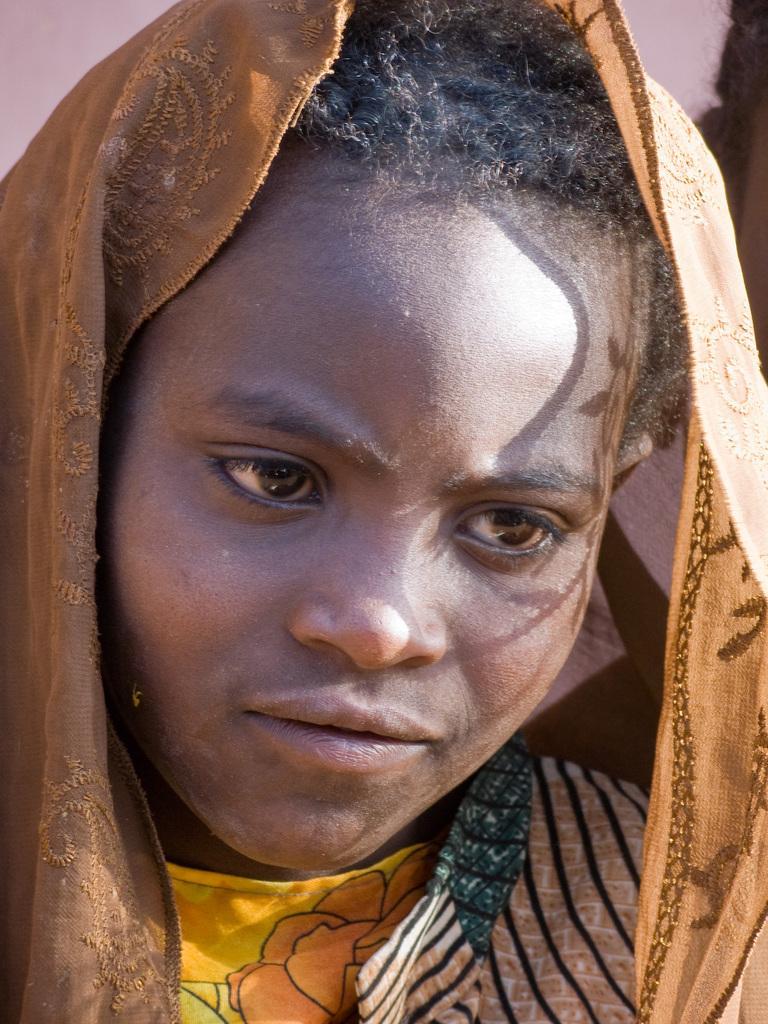Could you give a brief overview of what you see in this image? There is a person wearing a scarf on the head. 